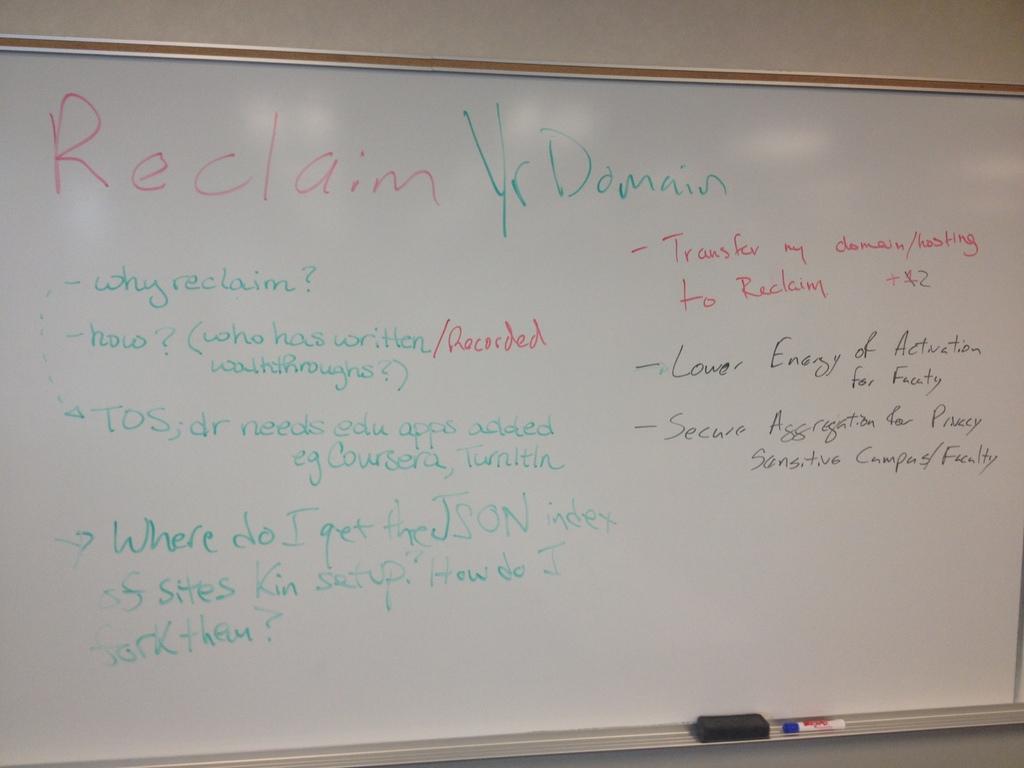What does it want to reclaim?
Ensure brevity in your answer.  Yr domain. What does it lower?
Your answer should be compact. Energy. 